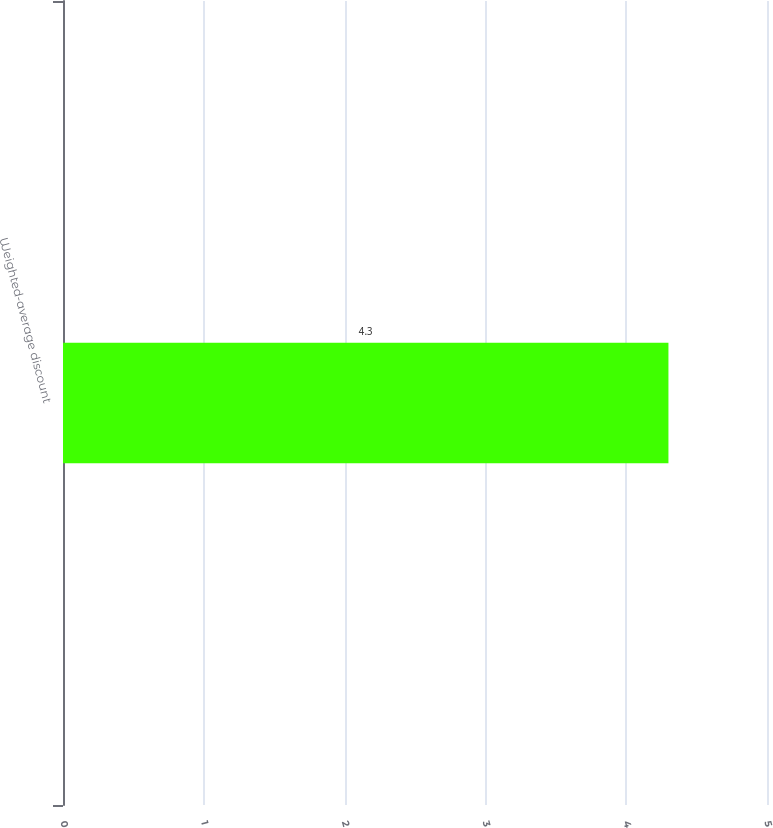<chart> <loc_0><loc_0><loc_500><loc_500><bar_chart><fcel>Weighted-average discount<nl><fcel>4.3<nl></chart> 